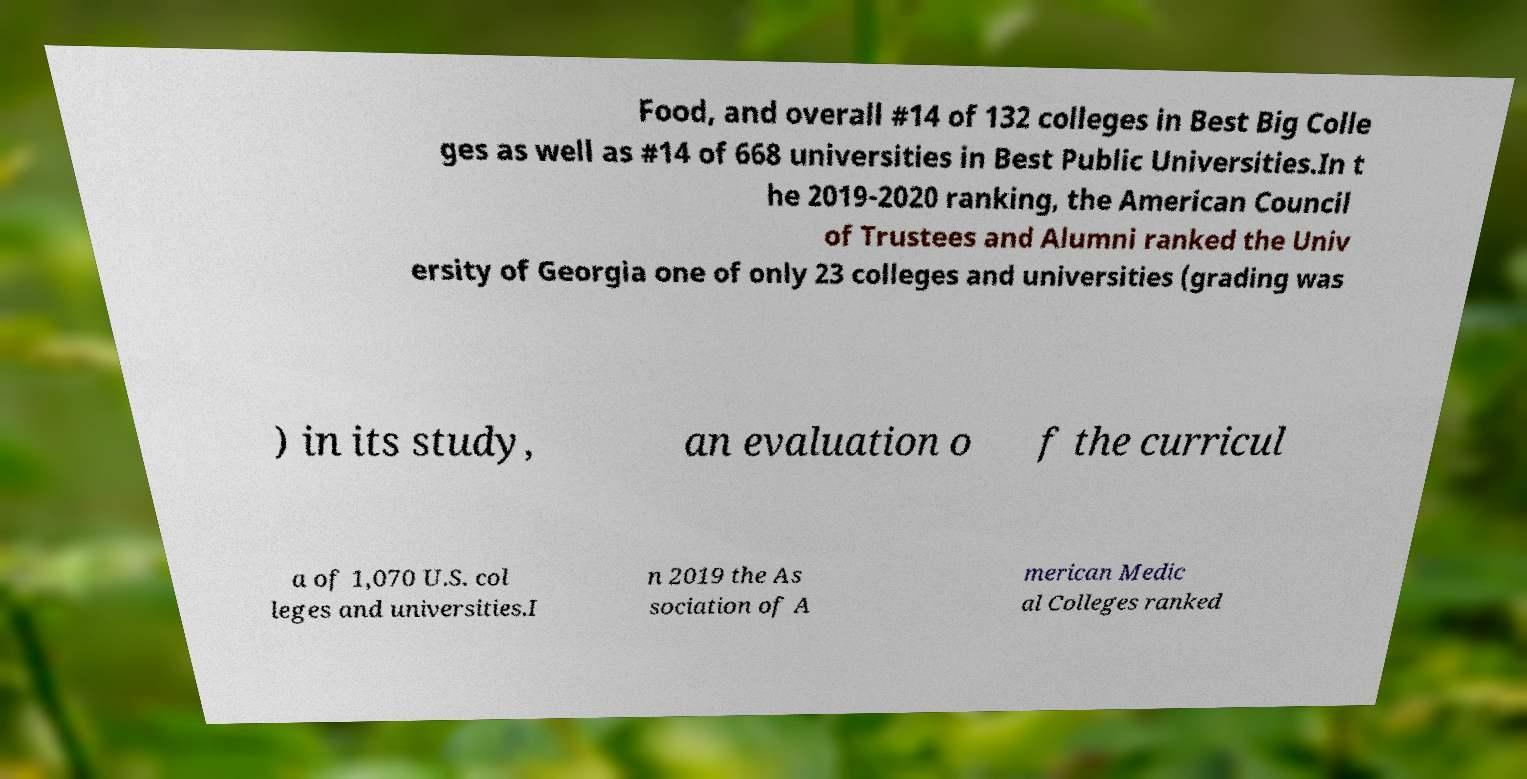I need the written content from this picture converted into text. Can you do that? Food, and overall #14 of 132 colleges in Best Big Colle ges as well as #14 of 668 universities in Best Public Universities.In t he 2019-2020 ranking, the American Council of Trustees and Alumni ranked the Univ ersity of Georgia one of only 23 colleges and universities (grading was ) in its study, an evaluation o f the curricul a of 1,070 U.S. col leges and universities.I n 2019 the As sociation of A merican Medic al Colleges ranked 